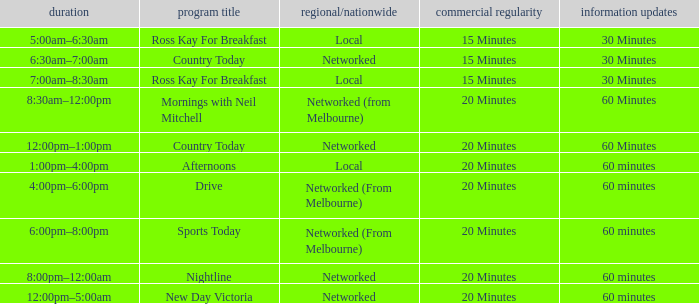What Time has a Show Name of mornings with neil mitchell? 8:30am–12:00pm. Could you parse the entire table? {'header': ['duration', 'program title', 'regional/nationwide', 'commercial regularity', 'information updates'], 'rows': [['5:00am–6:30am', 'Ross Kay For Breakfast', 'Local', '15 Minutes', '30 Minutes'], ['6:30am–7:00am', 'Country Today', 'Networked', '15 Minutes', '30 Minutes'], ['7:00am–8:30am', 'Ross Kay For Breakfast', 'Local', '15 Minutes', '30 Minutes'], ['8:30am–12:00pm', 'Mornings with Neil Mitchell', 'Networked (from Melbourne)', '20 Minutes', '60 Minutes'], ['12:00pm–1:00pm', 'Country Today', 'Networked', '20 Minutes', '60 Minutes'], ['1:00pm–4:00pm', 'Afternoons', 'Local', '20 Minutes', '60 minutes'], ['4:00pm–6:00pm', 'Drive', 'Networked (From Melbourne)', '20 Minutes', '60 minutes'], ['6:00pm–8:00pm', 'Sports Today', 'Networked (From Melbourne)', '20 Minutes', '60 minutes'], ['8:00pm–12:00am', 'Nightline', 'Networked', '20 Minutes', '60 minutes'], ['12:00pm–5:00am', 'New Day Victoria', 'Networked', '20 Minutes', '60 minutes']]} 